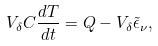<formula> <loc_0><loc_0><loc_500><loc_500>V _ { \delta } C \frac { d T } { d t } = Q - V _ { \delta } \tilde { \epsilon } _ { \nu } ,</formula> 